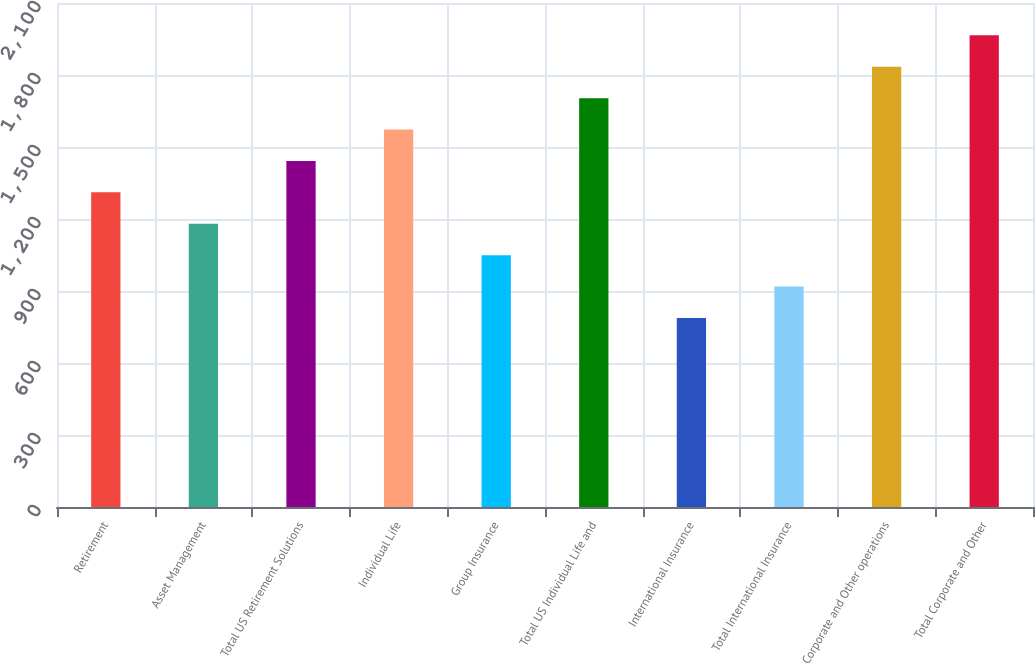Convert chart. <chart><loc_0><loc_0><loc_500><loc_500><bar_chart><fcel>Retirement<fcel>Asset Management<fcel>Total US Retirement Solutions<fcel>Individual Life<fcel>Group Insurance<fcel>Total US Individual Life and<fcel>International Insurance<fcel>Total International Insurance<fcel>Corporate and Other operations<fcel>Total Corporate and Other<nl><fcel>1311.01<fcel>1180.14<fcel>1441.88<fcel>1572.75<fcel>1049.28<fcel>1703.62<fcel>787.56<fcel>918.42<fcel>1834.48<fcel>1965.35<nl></chart> 